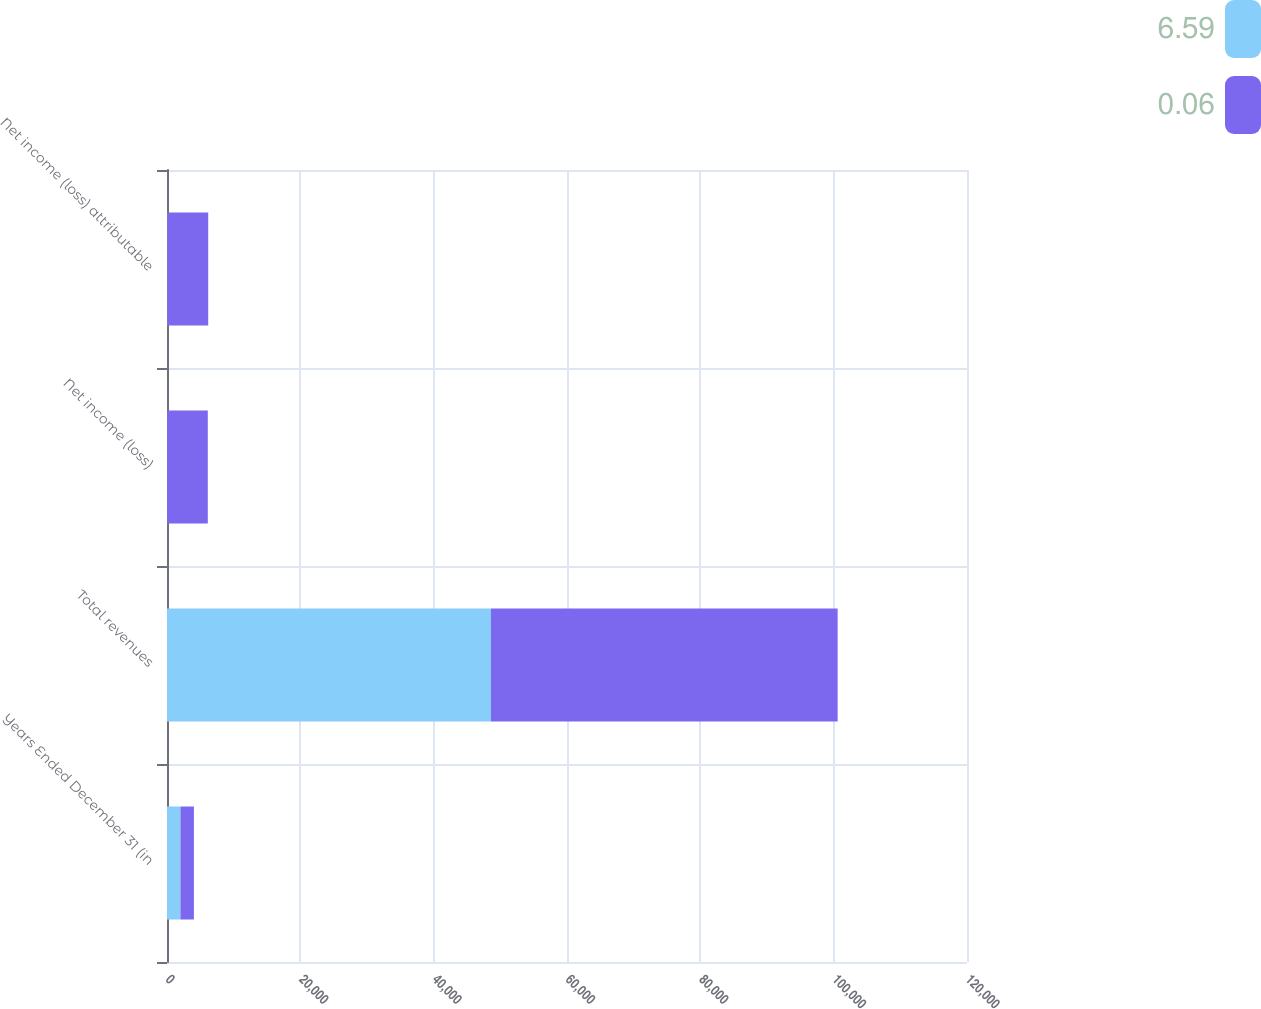Convert chart to OTSL. <chart><loc_0><loc_0><loc_500><loc_500><stacked_bar_chart><ecel><fcel>Years Ended December 31 (in<fcel>Total revenues<fcel>Net income (loss)<fcel>Net income (loss) attributable<nl><fcel>6.59<fcel>2018<fcel>48588<fcel>16<fcel>51<nl><fcel>0.06<fcel>2017<fcel>52009<fcel>6104<fcel>6132<nl></chart> 